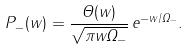<formula> <loc_0><loc_0><loc_500><loc_500>P _ { - } ( w ) = \frac { \Theta ( w ) } { \sqrt { \pi w \Omega _ { - } } } \, e ^ { - w / \Omega _ { - } } .</formula> 